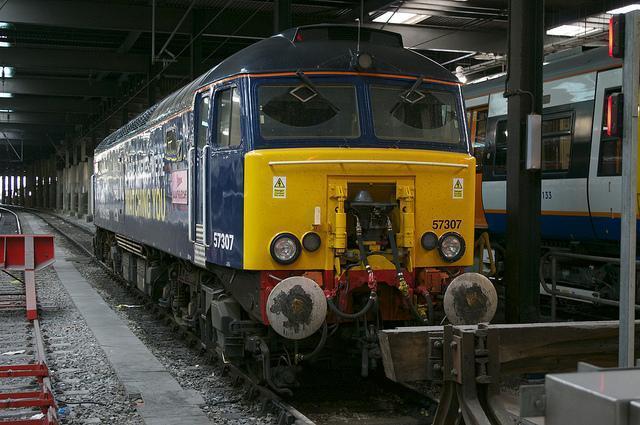How many trains are in the picture?
Give a very brief answer. 2. 